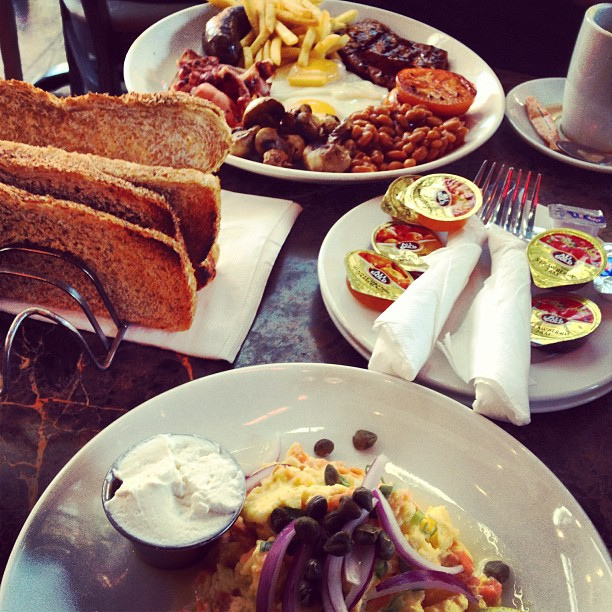Imagine a colorful insect landed on the table. What would it do? A colorful insect landing on the table might cautiously explore the different plates, possibly attracted to the sweet scent of the jelly or preserves. It might also be attracted to the warmth of the coffee cup. 